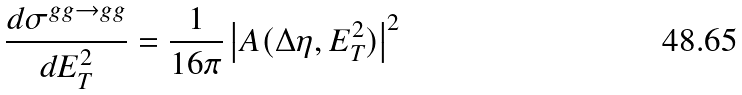<formula> <loc_0><loc_0><loc_500><loc_500>\frac { d \sigma ^ { g g \rightarrow g g } } { d E _ { T } ^ { 2 } } = \frac { 1 } { 1 6 \pi } \left | A ( \Delta \eta , E _ { T } ^ { 2 } ) \right | ^ { 2 }</formula> 